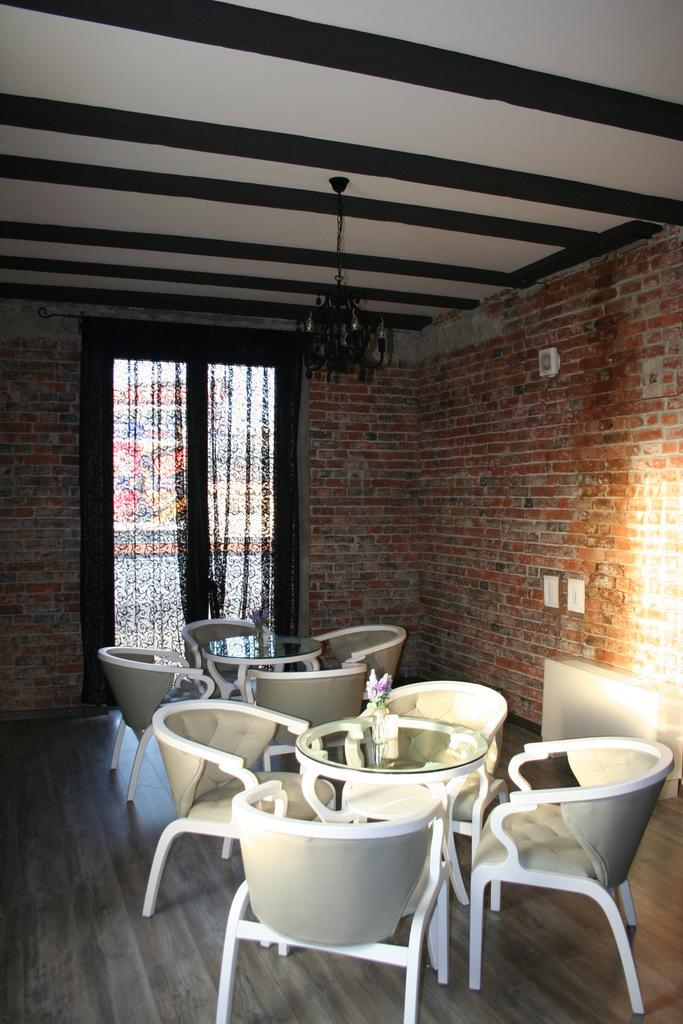What type of furniture is visible in the image? There are tables and chairs in the image. Where are the tables and chairs located? The tables and chairs are on the floor in the image. What can be seen in the background of the image? There is a wall and a window in the background of the image. What type of window treatment is present in the image? There are curtains associated with the window in the image. What type of fuel is being used by the actor in the image? There is no actor or fuel present in the image. The image features tables, chairs, a wall, a window, and curtains. 